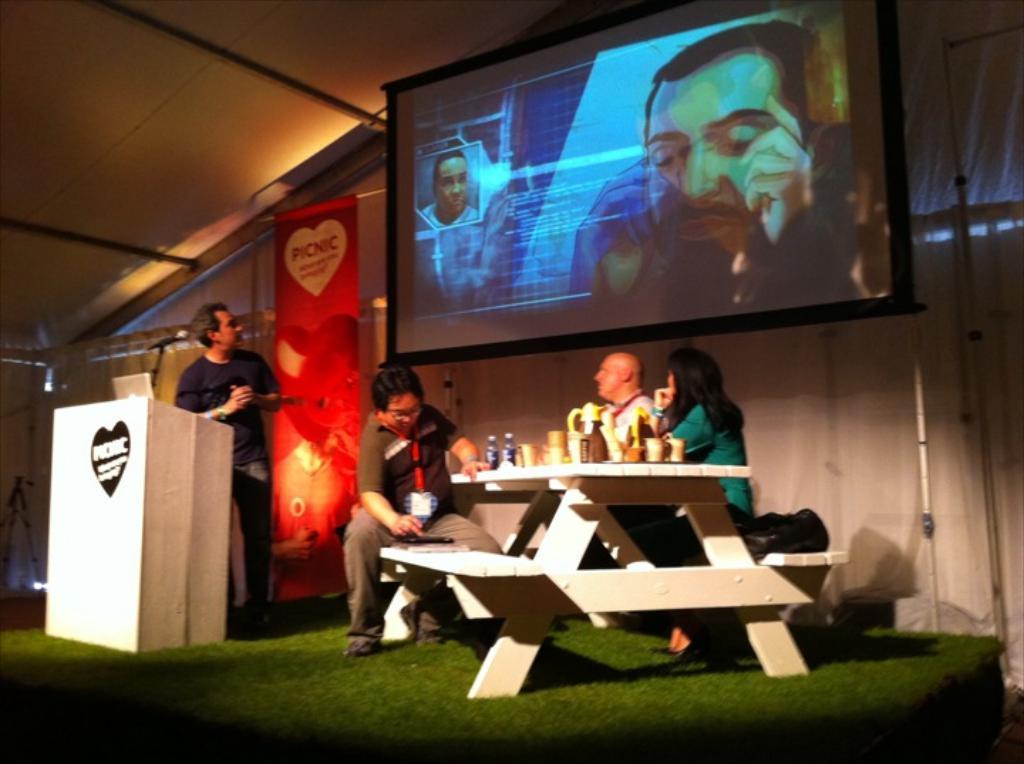Could you give a brief overview of what you see in this image? In this picture we can see three are sitting on the bench. This is table. On the table there are glasses, and bottles. Here we can see a man who is standing on the floor. This is mike. And on the background we can see a screen and this is wall. 